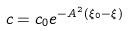Convert formula to latex. <formula><loc_0><loc_0><loc_500><loc_500>c = c _ { 0 } e ^ { - A ^ { 2 } ( \xi _ { 0 } - \xi ) }</formula> 